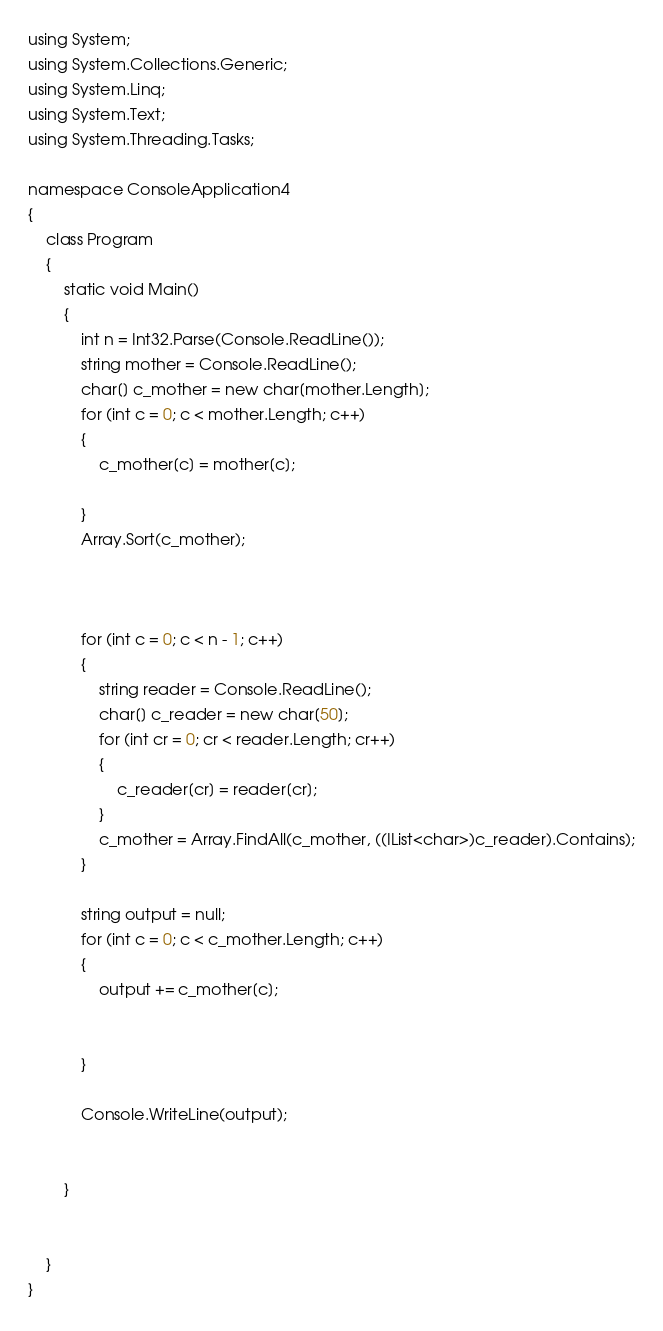<code> <loc_0><loc_0><loc_500><loc_500><_C#_>using System;
using System.Collections.Generic;
using System.Linq;
using System.Text;
using System.Threading.Tasks;

namespace ConsoleApplication4
{
    class Program
    {
        static void Main()
        {
            int n = Int32.Parse(Console.ReadLine());
            string mother = Console.ReadLine();
            char[] c_mother = new char[mother.Length];
            for (int c = 0; c < mother.Length; c++)
            {
                c_mother[c] = mother[c];

            }
            Array.Sort(c_mother);
            


            for (int c = 0; c < n - 1; c++)
            {
                string reader = Console.ReadLine();
                char[] c_reader = new char[50];
                for (int cr = 0; cr < reader.Length; cr++)
                {
                    c_reader[cr] = reader[cr];
                }
                c_mother = Array.FindAll(c_mother, ((IList<char>)c_reader).Contains);
            }

            string output = null;
            for (int c = 0; c < c_mother.Length; c++)
            {
                output += c_mother[c];


            }

            Console.WriteLine(output);
          
            
        }


    }
}
</code> 